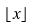Convert formula to latex. <formula><loc_0><loc_0><loc_500><loc_500>\lfloor x \rfloor</formula> 